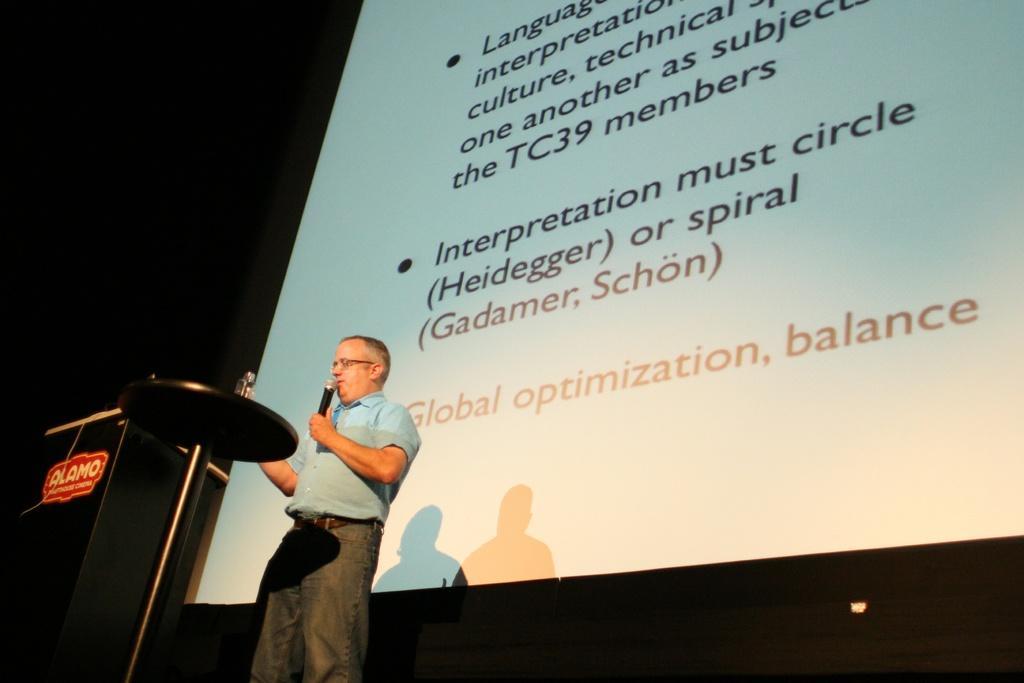Describe this image in one or two sentences. In this picture, we see a man in blue shirt is holding a microphone in his hand and he is talking on it. In front of him, we see a podium and behind him, we see a projector screen with some text displayed on it. On the left corner of the picture, it is black in color and this picture might be clicked in a conference hall. 